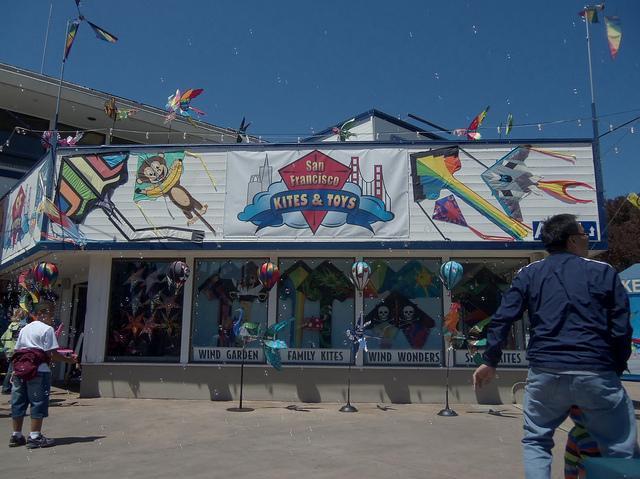How many people are there?
Give a very brief answer. 2. How many kites can be seen?
Give a very brief answer. 2. 